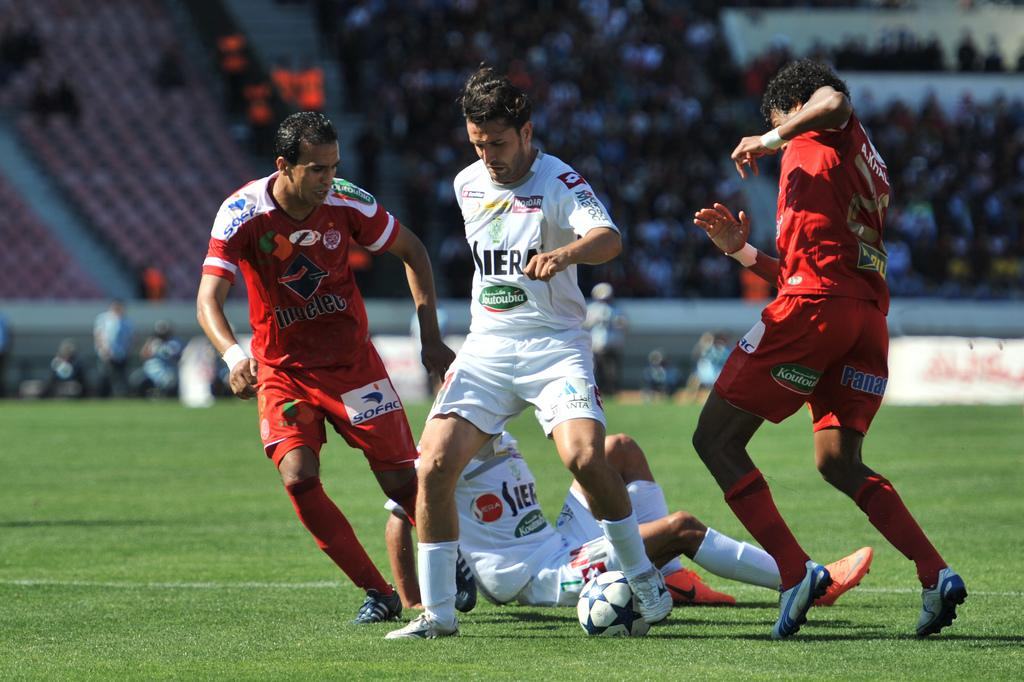How many people are playing football in the image? There are four men in the image, and they are playing football. What is the surface they are playing on? There is grass on the ground, which they are playing football on. Can you describe the background of the image? In the background of the image, there are people sitting on chairs. What type of animals can be seen in the zoo in the image? There is no zoo present in the image; it features four men playing football on a grassy field with people sitting on chairs in the background. 